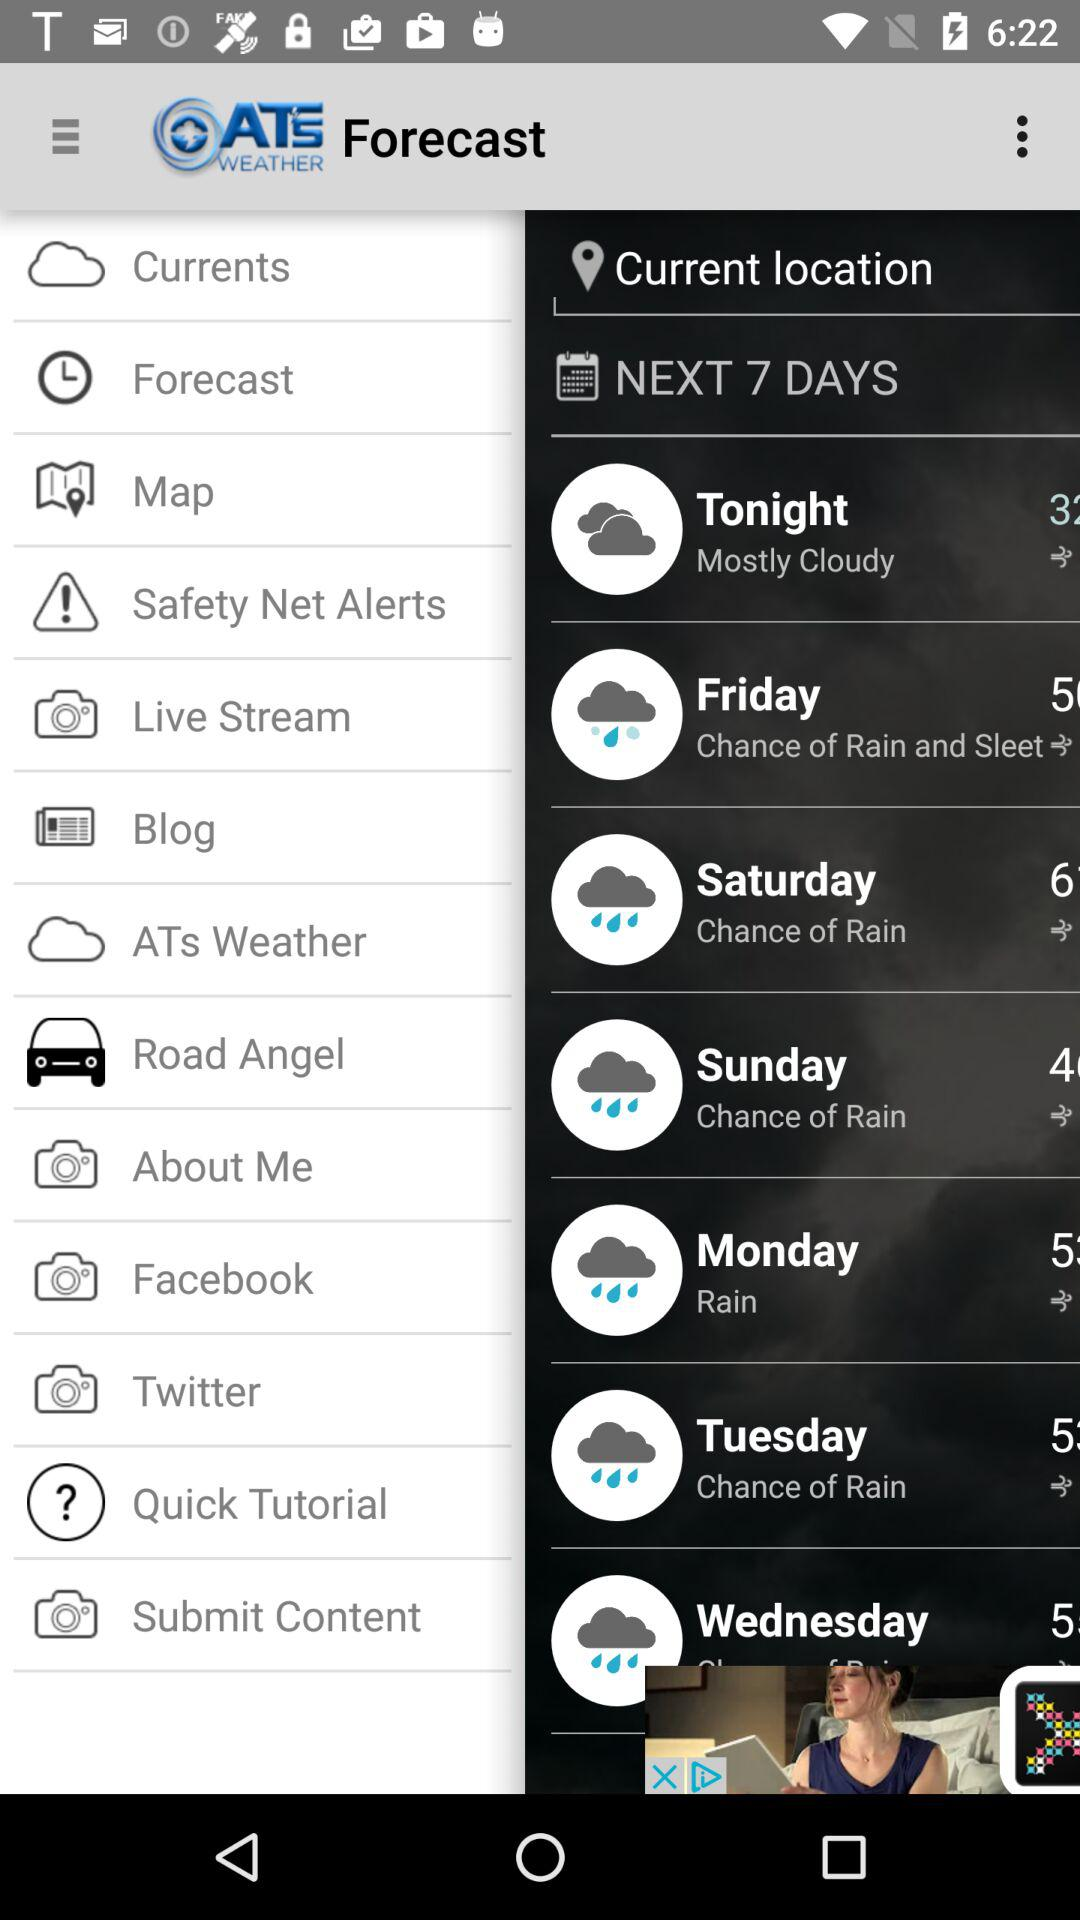On what day is it going to rain? The day it is going to rain is Monday. 